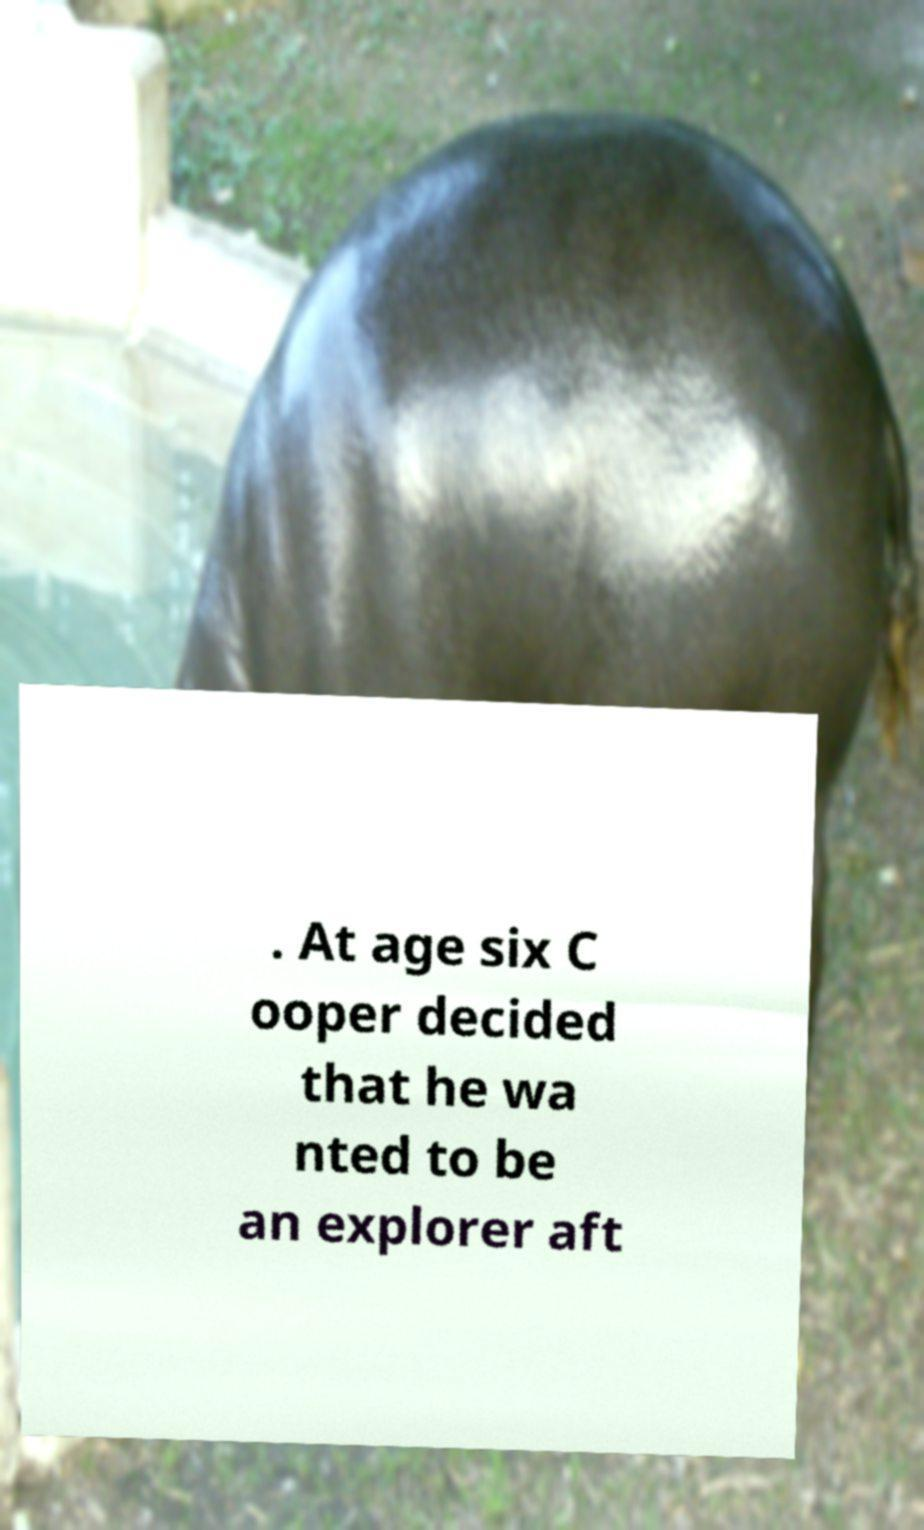What messages or text are displayed in this image? I need them in a readable, typed format. . At age six C ooper decided that he wa nted to be an explorer aft 